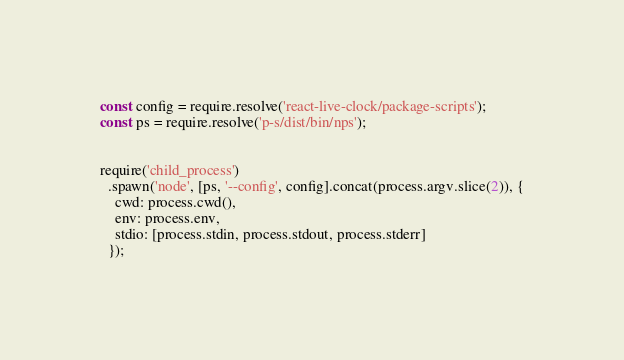<code> <loc_0><loc_0><loc_500><loc_500><_JavaScript_>const config = require.resolve('react-live-clock/package-scripts');
const ps = require.resolve('p-s/dist/bin/nps');


require('child_process')
  .spawn('node', [ps, '--config', config].concat(process.argv.slice(2)), {
    cwd: process.cwd(),
    env: process.env,
    stdio: [process.stdin, process.stdout, process.stderr]
  });
</code> 